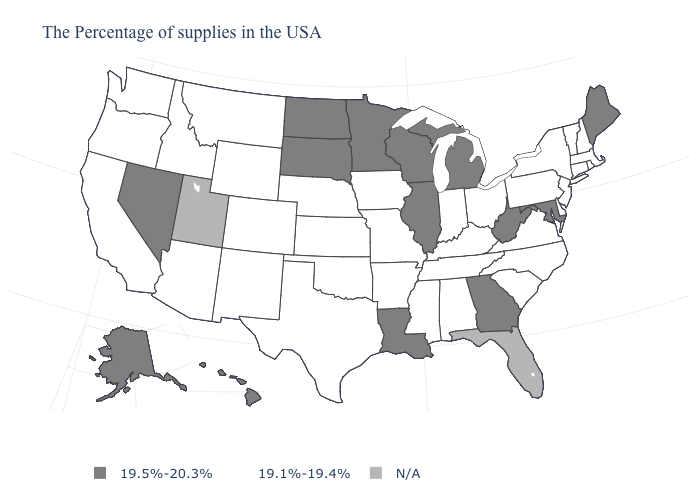Among the states that border Wyoming , which have the lowest value?
Give a very brief answer. Nebraska, Colorado, Montana, Idaho. Does Hawaii have the highest value in the West?
Keep it brief. Yes. Name the states that have a value in the range 19.5%-20.3%?
Quick response, please. Maine, Maryland, West Virginia, Georgia, Michigan, Wisconsin, Illinois, Louisiana, Minnesota, South Dakota, North Dakota, Nevada, Alaska, Hawaii. Name the states that have a value in the range 19.1%-19.4%?
Answer briefly. Massachusetts, Rhode Island, New Hampshire, Vermont, Connecticut, New York, New Jersey, Delaware, Pennsylvania, Virginia, North Carolina, South Carolina, Ohio, Kentucky, Indiana, Alabama, Tennessee, Mississippi, Missouri, Arkansas, Iowa, Kansas, Nebraska, Oklahoma, Texas, Wyoming, Colorado, New Mexico, Montana, Arizona, Idaho, California, Washington, Oregon. Does California have the lowest value in the West?
Keep it brief. Yes. How many symbols are there in the legend?
Be succinct. 3. Does Washington have the highest value in the USA?
Answer briefly. No. Among the states that border Arkansas , which have the lowest value?
Short answer required. Tennessee, Mississippi, Missouri, Oklahoma, Texas. Which states have the highest value in the USA?
Concise answer only. Maine, Maryland, West Virginia, Georgia, Michigan, Wisconsin, Illinois, Louisiana, Minnesota, South Dakota, North Dakota, Nevada, Alaska, Hawaii. What is the value of New Jersey?
Give a very brief answer. 19.1%-19.4%. What is the lowest value in the USA?
Answer briefly. 19.1%-19.4%. What is the lowest value in states that border Delaware?
Short answer required. 19.1%-19.4%. Name the states that have a value in the range N/A?
Concise answer only. Florida, Utah. Name the states that have a value in the range 19.5%-20.3%?
Answer briefly. Maine, Maryland, West Virginia, Georgia, Michigan, Wisconsin, Illinois, Louisiana, Minnesota, South Dakota, North Dakota, Nevada, Alaska, Hawaii. Name the states that have a value in the range N/A?
Short answer required. Florida, Utah. 